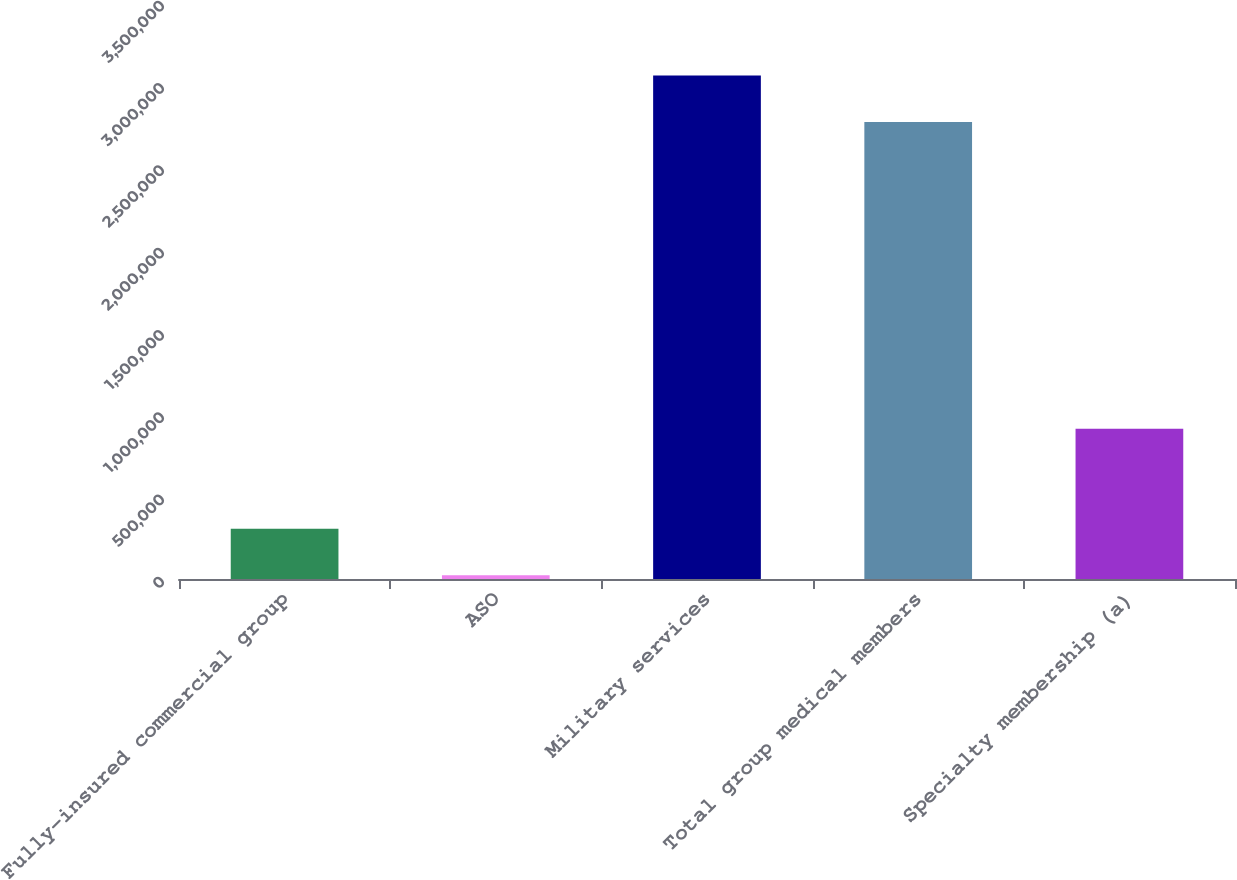Convert chart. <chart><loc_0><loc_0><loc_500><loc_500><bar_chart><fcel>Fully-insured commercial group<fcel>ASO<fcel>Military services<fcel>Total group medical members<fcel>Specialty membership (a)<nl><fcel>305560<fcel>23200<fcel>3.05936e+06<fcel>2.777e+06<fcel>913700<nl></chart> 